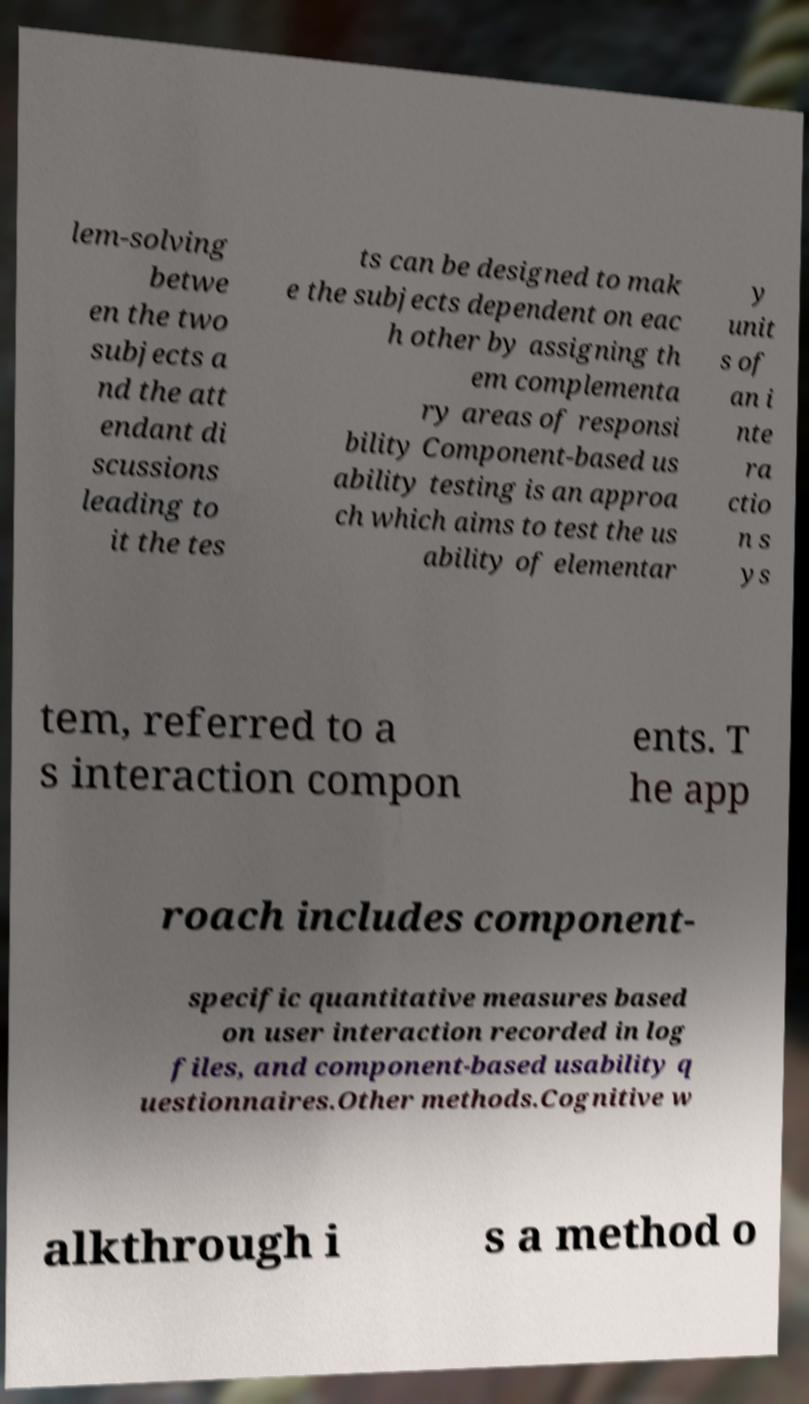There's text embedded in this image that I need extracted. Can you transcribe it verbatim? lem-solving betwe en the two subjects a nd the att endant di scussions leading to it the tes ts can be designed to mak e the subjects dependent on eac h other by assigning th em complementa ry areas of responsi bility Component-based us ability testing is an approa ch which aims to test the us ability of elementar y unit s of an i nte ra ctio n s ys tem, referred to a s interaction compon ents. T he app roach includes component- specific quantitative measures based on user interaction recorded in log files, and component-based usability q uestionnaires.Other methods.Cognitive w alkthrough i s a method o 